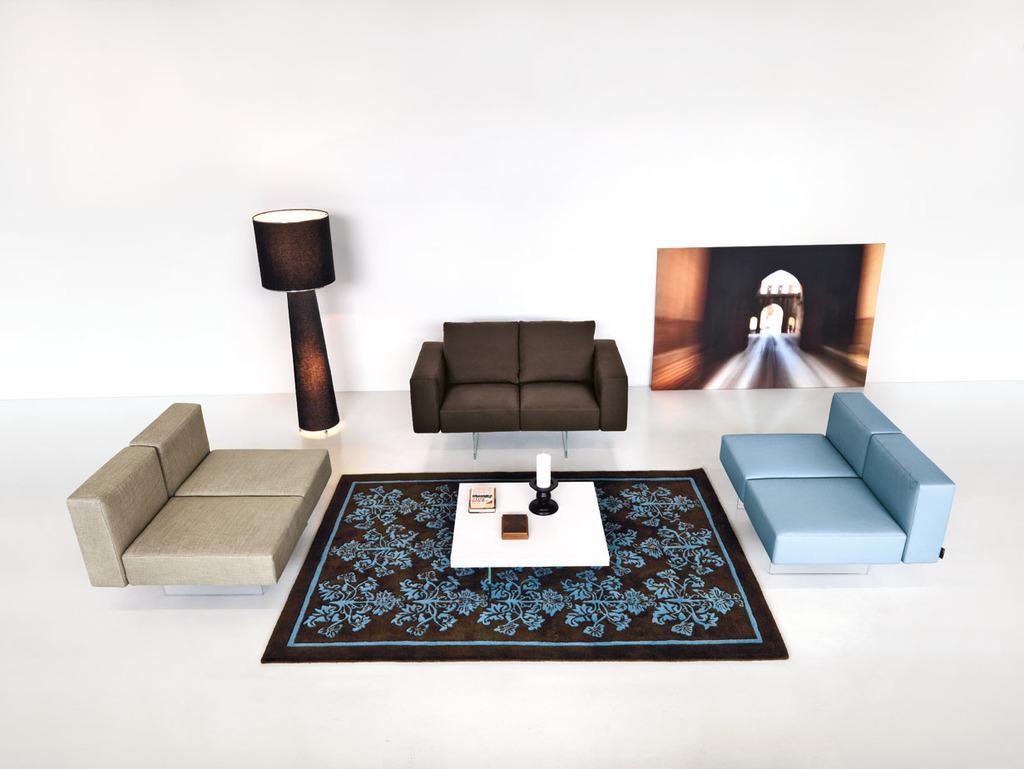Describe this image in one or two sentences. In this image, There is a floor which is in white color, In the middle there is a black color cloth on that there is a white color table on that table there is a black color object, There is a black color sofa in the middle, In the right side there is a blue color sofa, In the left side there is a gray color sofa, There is a black color light, In the background there is a white color wall. 